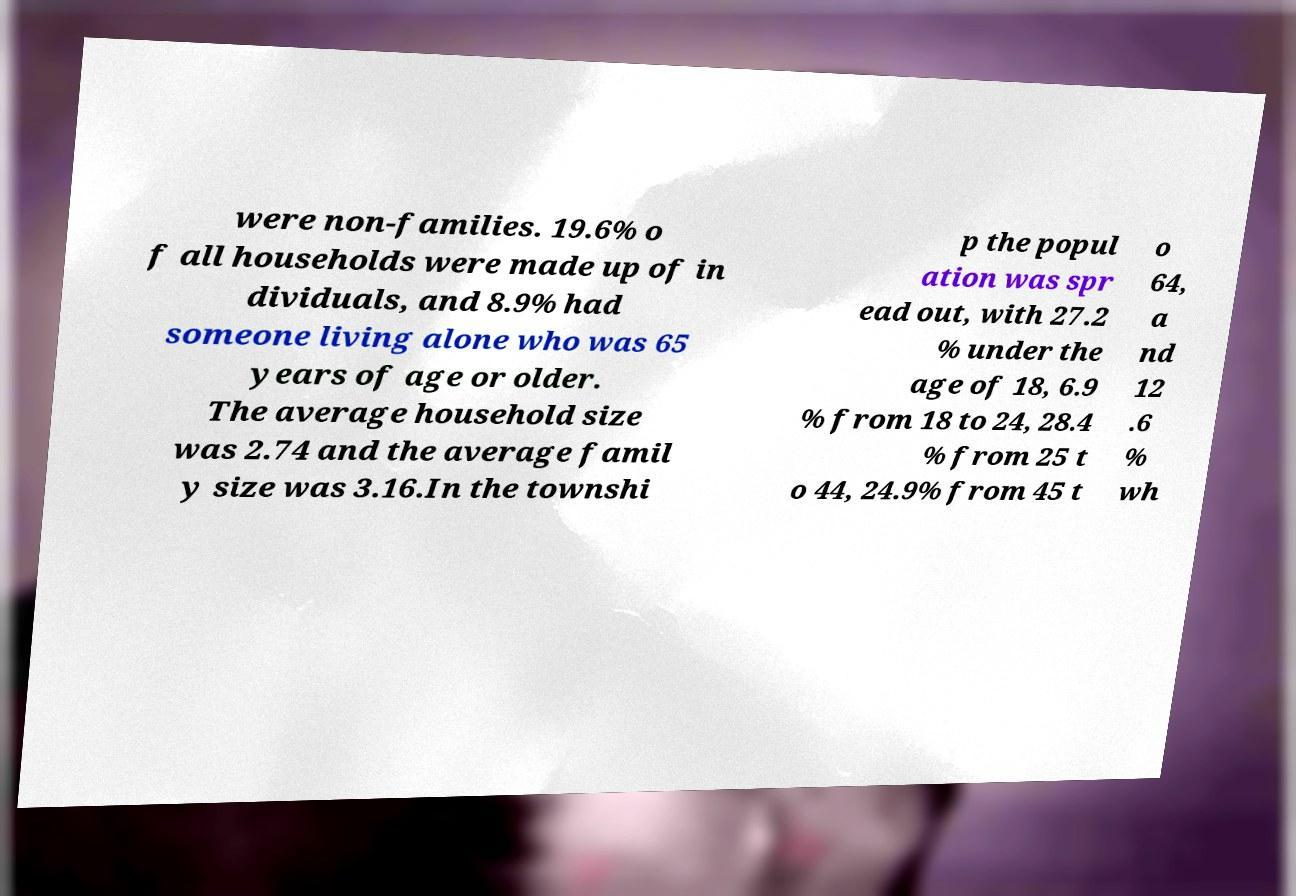Can you read and provide the text displayed in the image?This photo seems to have some interesting text. Can you extract and type it out for me? were non-families. 19.6% o f all households were made up of in dividuals, and 8.9% had someone living alone who was 65 years of age or older. The average household size was 2.74 and the average famil y size was 3.16.In the townshi p the popul ation was spr ead out, with 27.2 % under the age of 18, 6.9 % from 18 to 24, 28.4 % from 25 t o 44, 24.9% from 45 t o 64, a nd 12 .6 % wh 